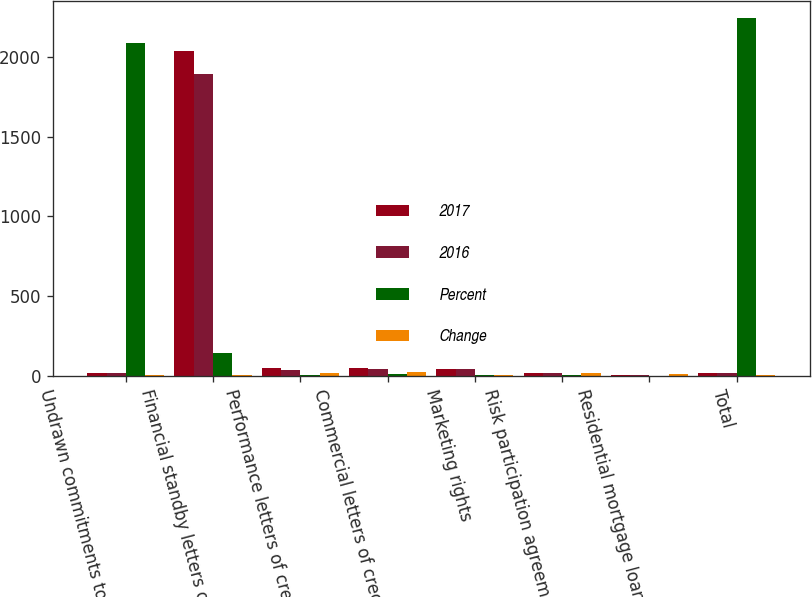Convert chart. <chart><loc_0><loc_0><loc_500><loc_500><stacked_bar_chart><ecel><fcel>Undrawn commitments to extend<fcel>Financial standby letters of<fcel>Performance letters of credit<fcel>Commercial letters of credit<fcel>Marketing rights<fcel>Risk participation agreements<fcel>Residential mortgage loans<fcel>Total<nl><fcel>2017<fcel>17<fcel>2036<fcel>47<fcel>53<fcel>41<fcel>16<fcel>7<fcel>17<nl><fcel>2016<fcel>17<fcel>1892<fcel>40<fcel>43<fcel>44<fcel>19<fcel>8<fcel>17<nl><fcel>Percent<fcel>2087<fcel>144<fcel>7<fcel>10<fcel>3<fcel>3<fcel>1<fcel>2241<nl><fcel>Change<fcel>3<fcel>8<fcel>18<fcel>23<fcel>7<fcel>16<fcel>13<fcel>4<nl></chart> 